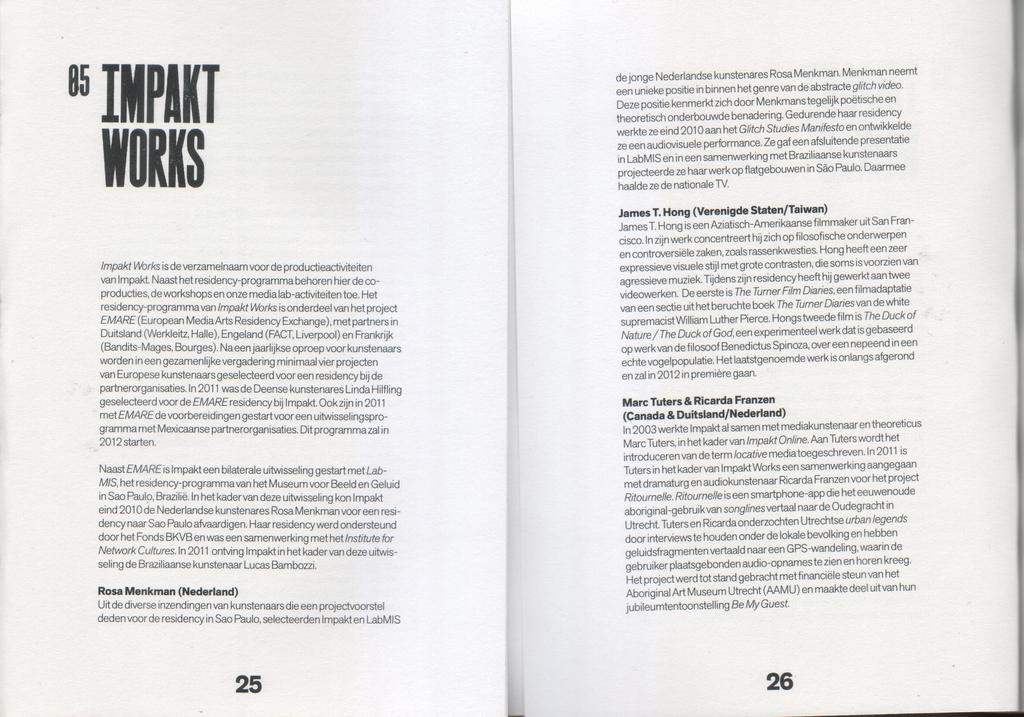What is this section titled?
Offer a very short reply. Impakt works. What pages are these?
Provide a short and direct response. 25 and 26. 